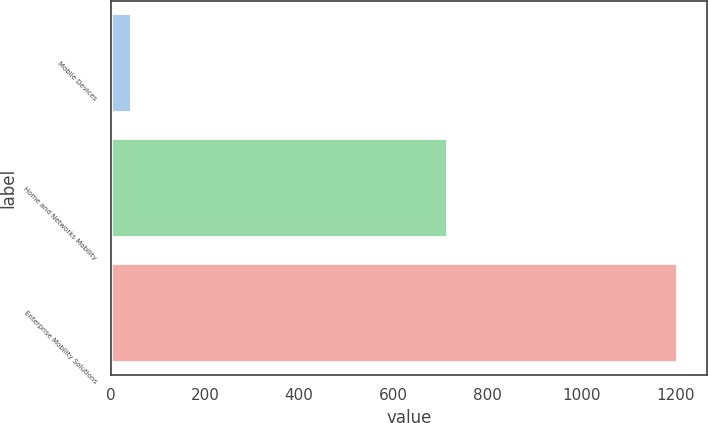Convert chart. <chart><loc_0><loc_0><loc_500><loc_500><bar_chart><fcel>Mobile Devices<fcel>Home and Networks Mobility<fcel>Enterprise Mobility Solutions<nl><fcel>45<fcel>716<fcel>1207<nl></chart> 